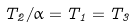<formula> <loc_0><loc_0><loc_500><loc_500>T _ { 2 } / \alpha = T _ { 1 } = T _ { 3 }</formula> 